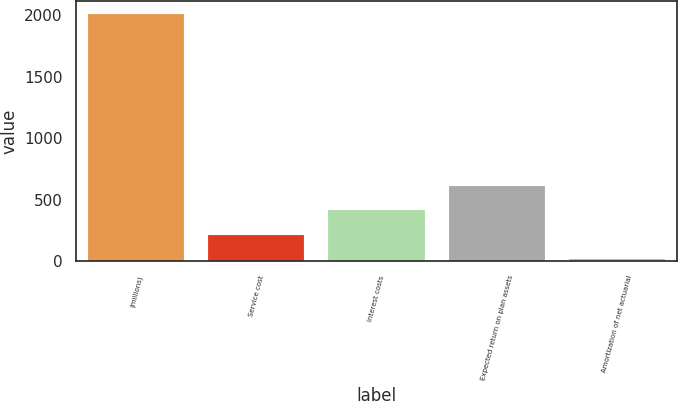<chart> <loc_0><loc_0><loc_500><loc_500><bar_chart><fcel>(millions)<fcel>Service cost<fcel>Interest costs<fcel>Expected return on plan assets<fcel>Amortization of net actuarial<nl><fcel>2015<fcel>216.62<fcel>416.44<fcel>616.26<fcel>16.8<nl></chart> 